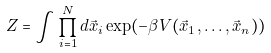<formula> <loc_0><loc_0><loc_500><loc_500>Z = \int \prod _ { i = 1 } ^ { N } d \vec { x } _ { i } \exp ( - \beta V ( \vec { x } _ { 1 } , \dots , \vec { x } _ { n } ) )</formula> 